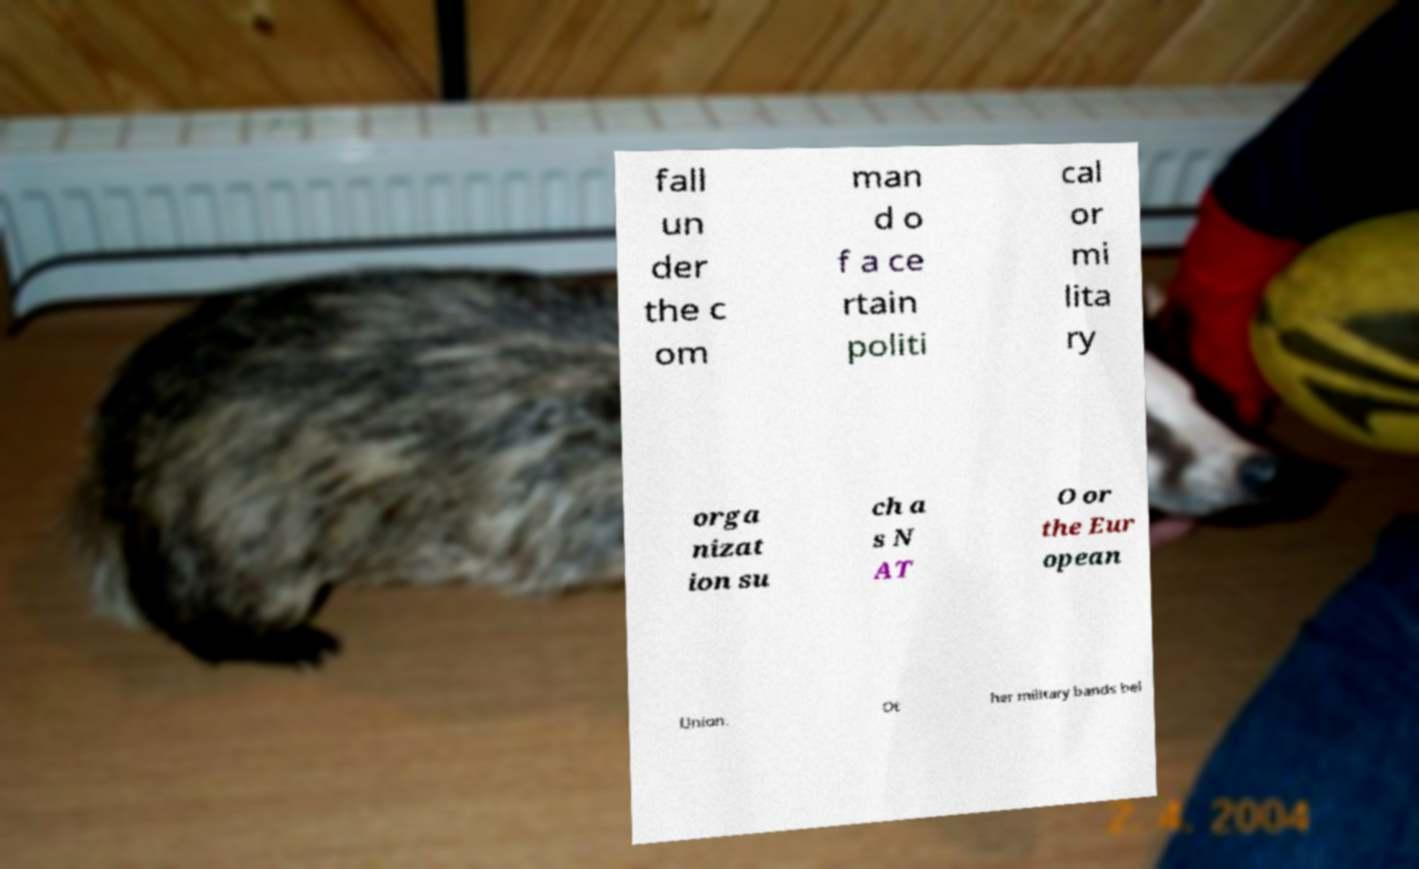Could you assist in decoding the text presented in this image and type it out clearly? fall un der the c om man d o f a ce rtain politi cal or mi lita ry orga nizat ion su ch a s N AT O or the Eur opean Union. Ot her military bands bel 